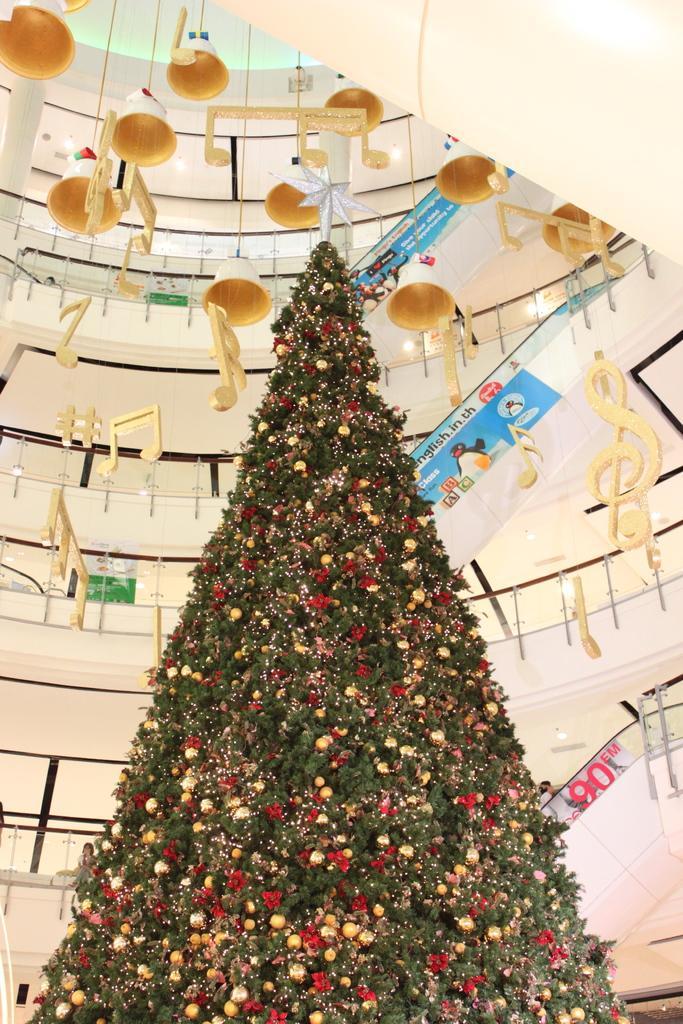How would you summarize this image in a sentence or two? In the center of the image we can see the Christmas tree. In the background we can see the building with railing. We can also see the decoration items hanged from the ceiling. We can also see the banners with text. 